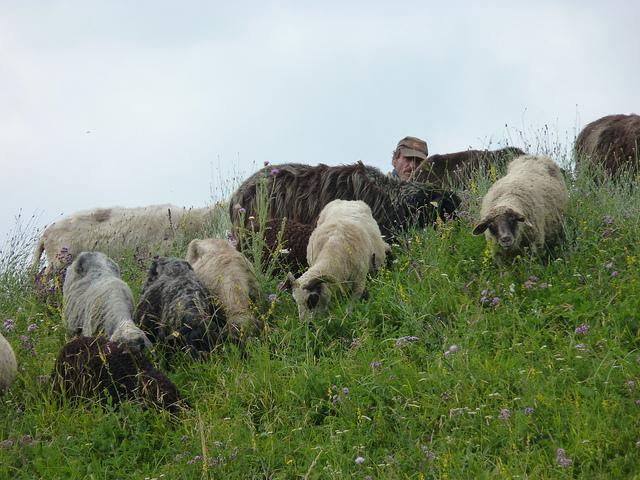How many sheep are there?
Answer briefly. 10. Is the sky overcast in this picture?
Keep it brief. Yes. Is a guy in the picture?
Quick response, please. Yes. 